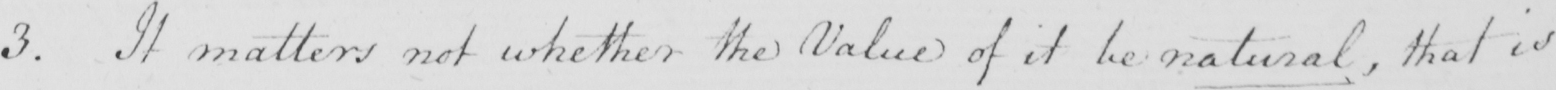Please transcribe the handwritten text in this image. 3 . It matters not whether the Value of it be natural , that is 